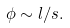Convert formula to latex. <formula><loc_0><loc_0><loc_500><loc_500>\phi \sim l / s .</formula> 